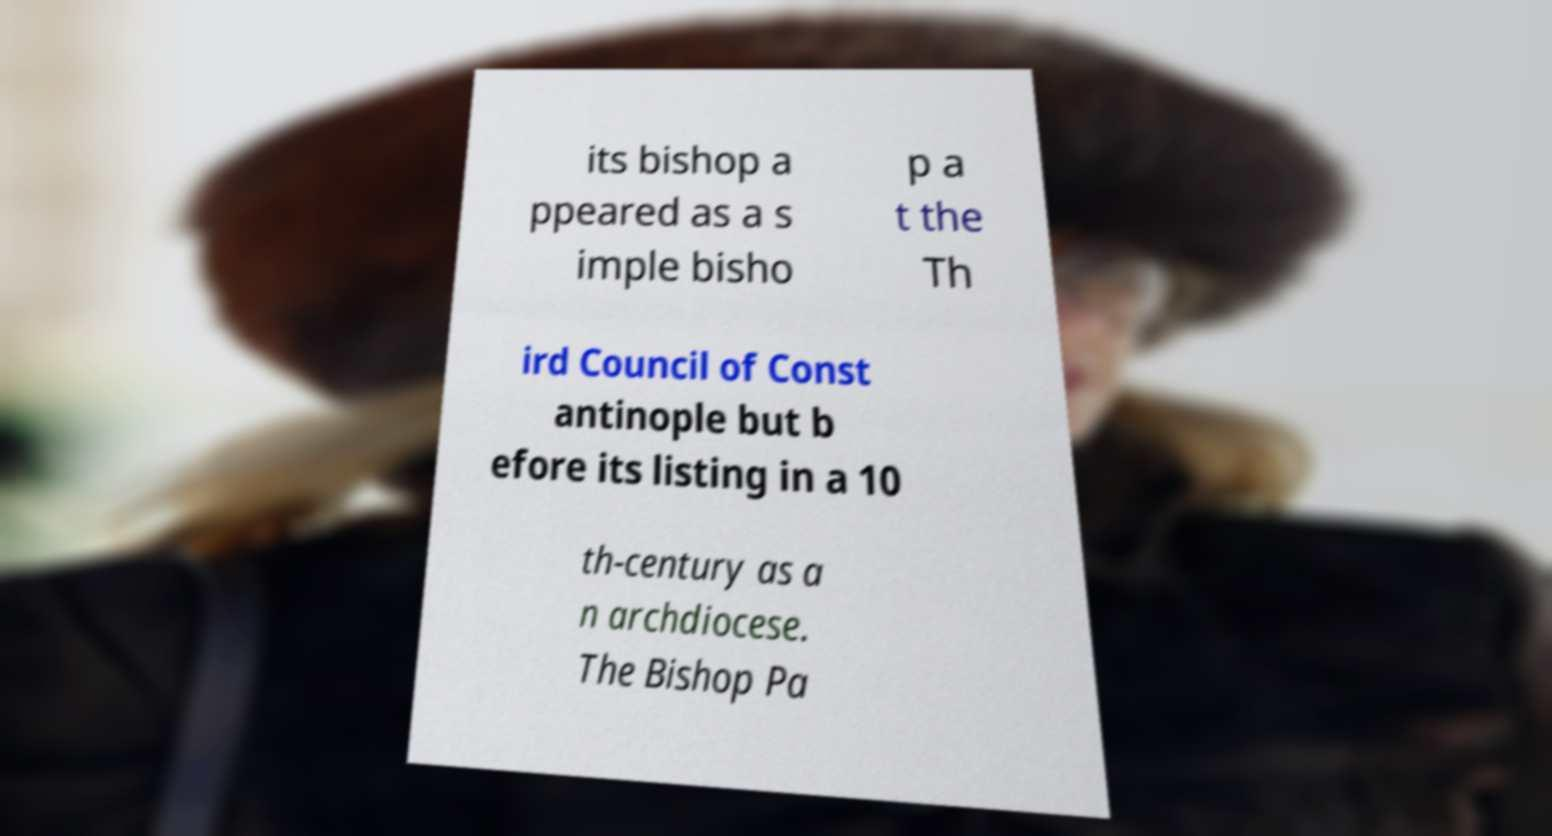What messages or text are displayed in this image? I need them in a readable, typed format. its bishop a ppeared as a s imple bisho p a t the Th ird Council of Const antinople but b efore its listing in a 10 th-century as a n archdiocese. The Bishop Pa 